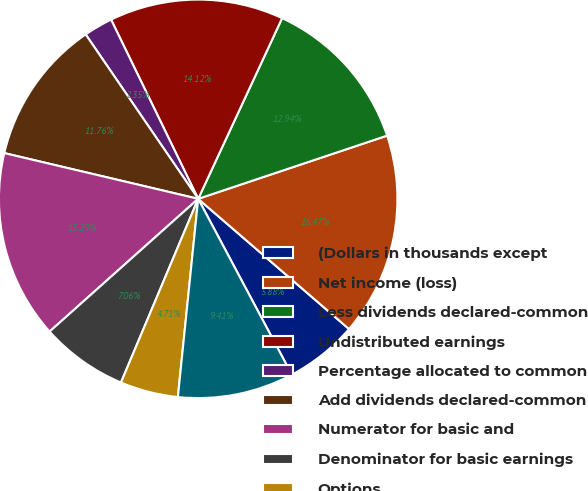Convert chart to OTSL. <chart><loc_0><loc_0><loc_500><loc_500><pie_chart><fcel>(Dollars in thousands except<fcel>Net income (loss)<fcel>Less dividends declared-common<fcel>Undistributed earnings<fcel>Percentage allocated to common<fcel>Add dividends declared-common<fcel>Numerator for basic and<fcel>Denominator for basic earnings<fcel>Options<fcel>Denominator for diluted<nl><fcel>5.88%<fcel>16.47%<fcel>12.94%<fcel>14.12%<fcel>2.35%<fcel>11.76%<fcel>15.29%<fcel>7.06%<fcel>4.71%<fcel>9.41%<nl></chart> 